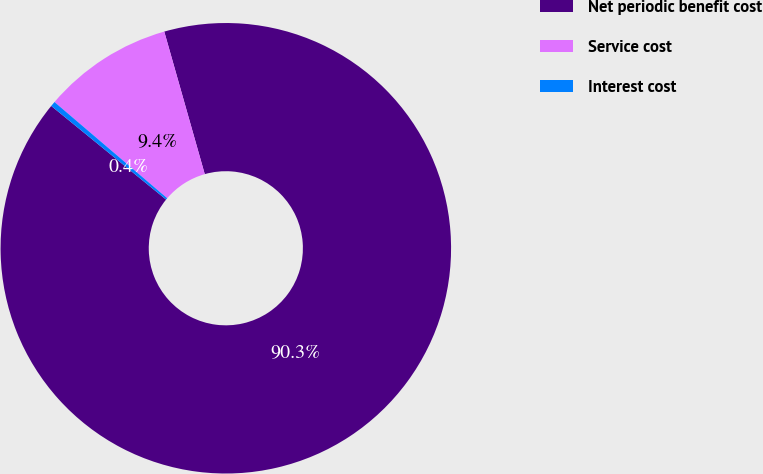Convert chart. <chart><loc_0><loc_0><loc_500><loc_500><pie_chart><fcel>Net periodic benefit cost<fcel>Service cost<fcel>Interest cost<nl><fcel>90.29%<fcel>9.35%<fcel>0.36%<nl></chart> 